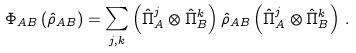<formula> <loc_0><loc_0><loc_500><loc_500>\Phi _ { A B } \left ( \hat { \rho } _ { A B } \right ) = \sum _ { j , k } \left ( \hat { \Pi } _ { A } ^ { j } \otimes \hat { \Pi } _ { B } ^ { k } \right ) \hat { \rho } _ { A B } \left ( \hat { \Pi } _ { A } ^ { j } \otimes \hat { \Pi } _ { B } ^ { k } \right ) \, .</formula> 